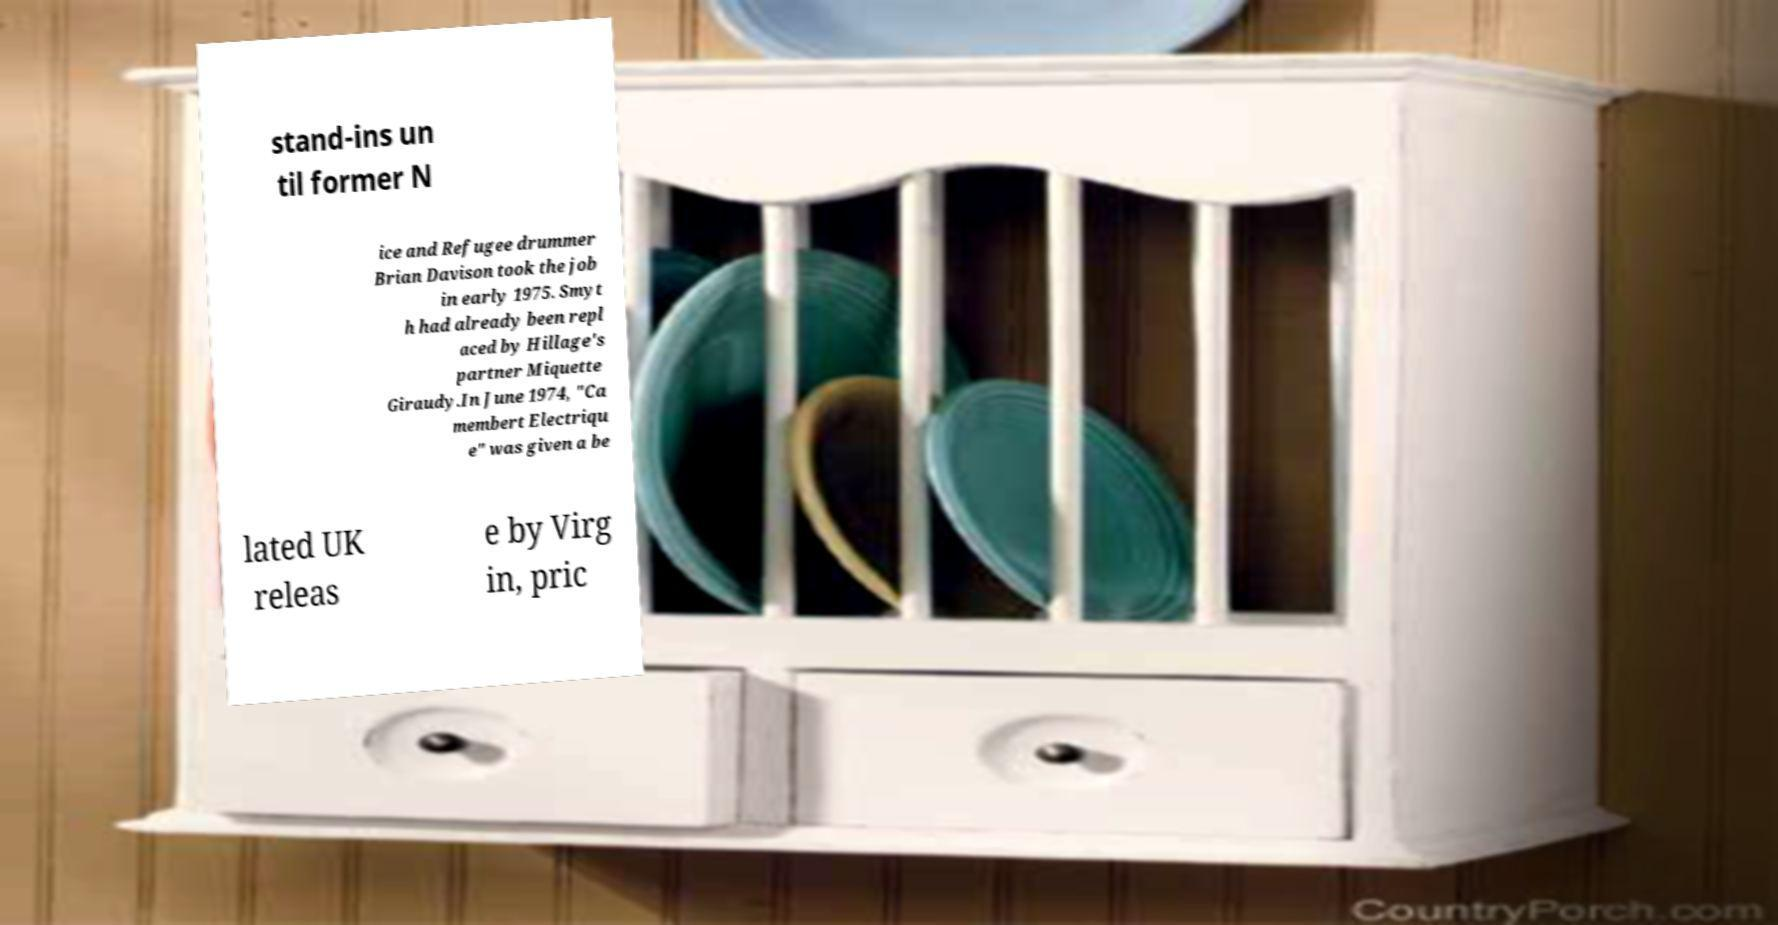Could you assist in decoding the text presented in this image and type it out clearly? stand-ins un til former N ice and Refugee drummer Brian Davison took the job in early 1975. Smyt h had already been repl aced by Hillage's partner Miquette Giraudy.In June 1974, "Ca membert Electriqu e" was given a be lated UK releas e by Virg in, pric 